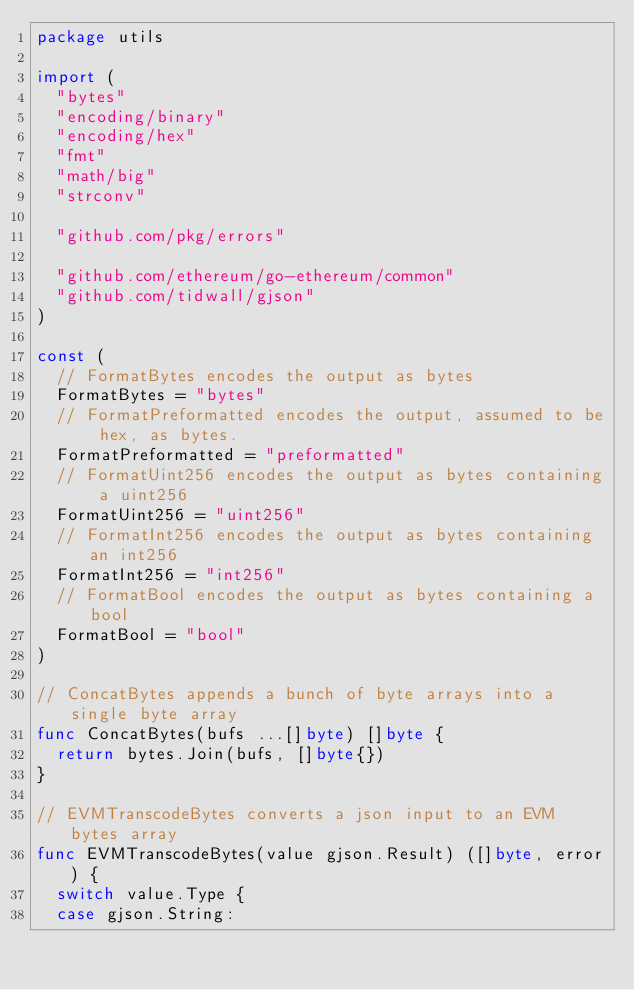Convert code to text. <code><loc_0><loc_0><loc_500><loc_500><_Go_>package utils

import (
	"bytes"
	"encoding/binary"
	"encoding/hex"
	"fmt"
	"math/big"
	"strconv"

	"github.com/pkg/errors"

	"github.com/ethereum/go-ethereum/common"
	"github.com/tidwall/gjson"
)

const (
	// FormatBytes encodes the output as bytes
	FormatBytes = "bytes"
	// FormatPreformatted encodes the output, assumed to be hex, as bytes.
	FormatPreformatted = "preformatted"
	// FormatUint256 encodes the output as bytes containing a uint256
	FormatUint256 = "uint256"
	// FormatInt256 encodes the output as bytes containing an int256
	FormatInt256 = "int256"
	// FormatBool encodes the output as bytes containing a bool
	FormatBool = "bool"
)

// ConcatBytes appends a bunch of byte arrays into a single byte array
func ConcatBytes(bufs ...[]byte) []byte {
	return bytes.Join(bufs, []byte{})
}

// EVMTranscodeBytes converts a json input to an EVM bytes array
func EVMTranscodeBytes(value gjson.Result) ([]byte, error) {
	switch value.Type {
	case gjson.String:</code> 